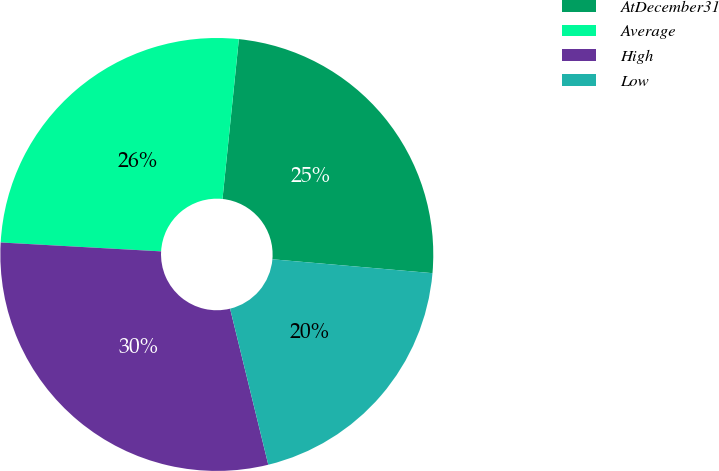Convert chart to OTSL. <chart><loc_0><loc_0><loc_500><loc_500><pie_chart><fcel>AtDecember31<fcel>Average<fcel>High<fcel>Low<nl><fcel>24.75%<fcel>25.74%<fcel>29.7%<fcel>19.8%<nl></chart> 